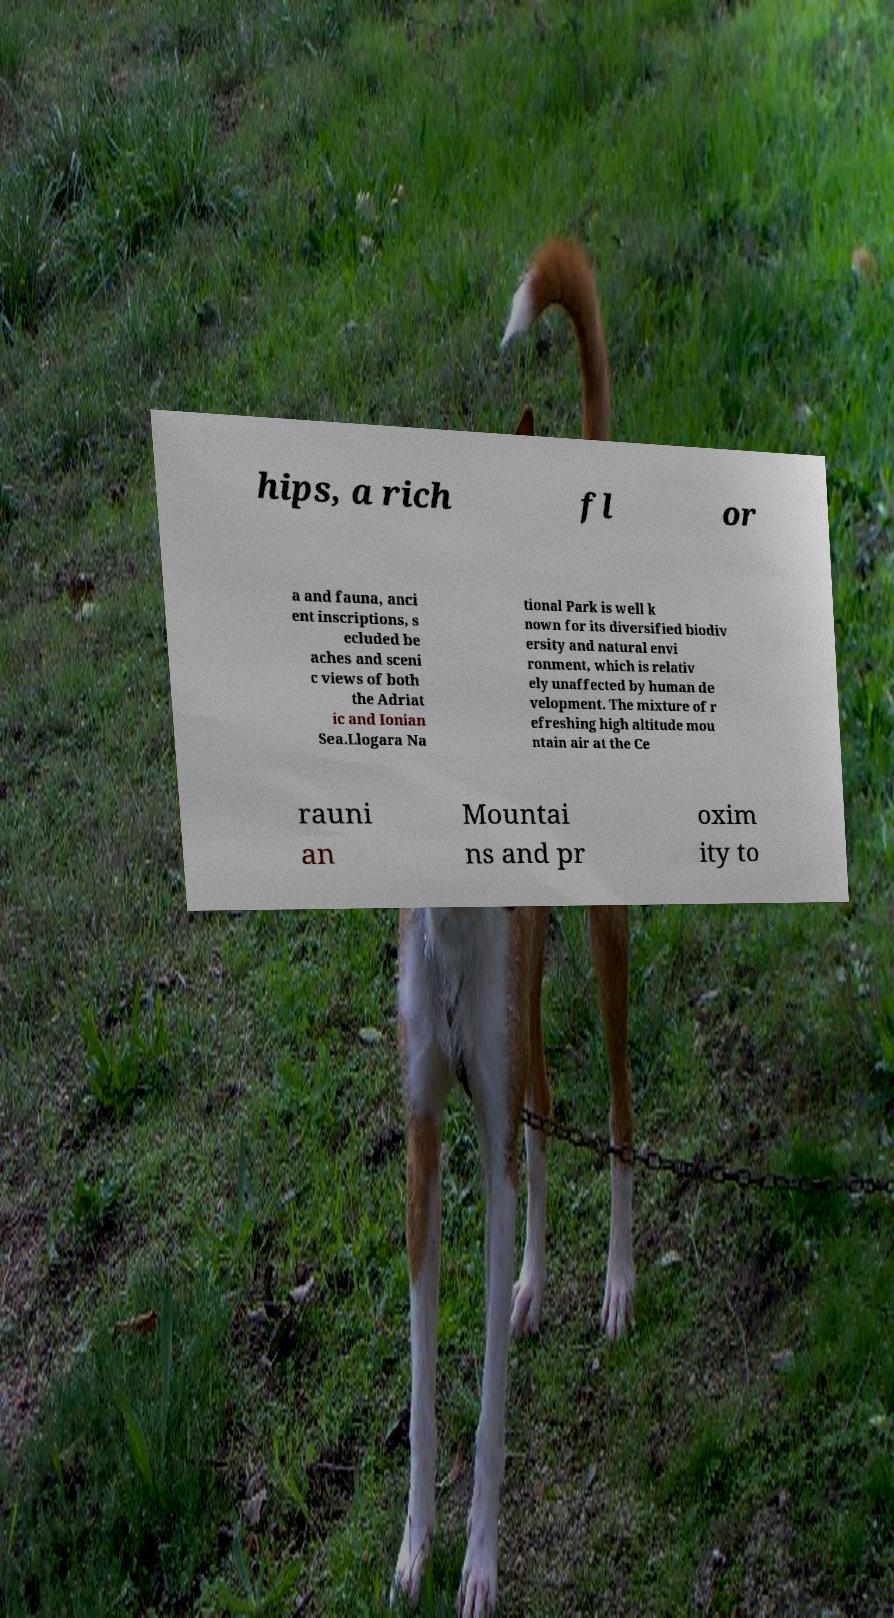Can you read and provide the text displayed in the image?This photo seems to have some interesting text. Can you extract and type it out for me? hips, a rich fl or a and fauna, anci ent inscriptions, s ecluded be aches and sceni c views of both the Adriat ic and Ionian Sea.Llogara Na tional Park is well k nown for its diversified biodiv ersity and natural envi ronment, which is relativ ely unaffected by human de velopment. The mixture of r efreshing high altitude mou ntain air at the Ce rauni an Mountai ns and pr oxim ity to 